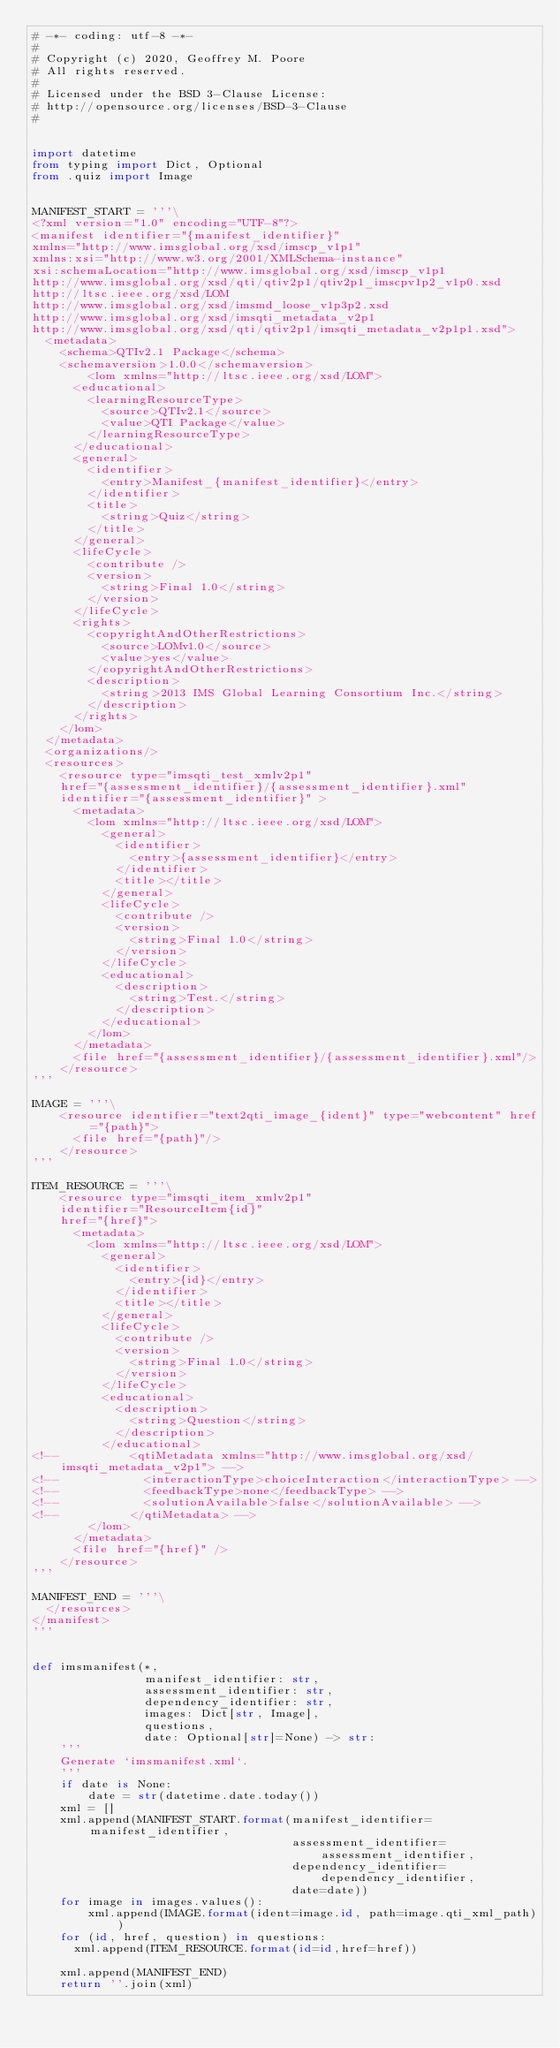<code> <loc_0><loc_0><loc_500><loc_500><_Python_># -*- coding: utf-8 -*-
#
# Copyright (c) 2020, Geoffrey M. Poore
# All rights reserved.
#
# Licensed under the BSD 3-Clause License:
# http://opensource.org/licenses/BSD-3-Clause
#


import datetime
from typing import Dict, Optional
from .quiz import Image


MANIFEST_START = '''\
<?xml version="1.0" encoding="UTF-8"?>
<manifest identifier="{manifest_identifier}"
xmlns="http://www.imsglobal.org/xsd/imscp_v1p1"
xmlns:xsi="http://www.w3.org/2001/XMLSchema-instance" 
xsi:schemaLocation="http://www.imsglobal.org/xsd/imscp_v1p1
http://www.imsglobal.org/xsd/qti/qtiv2p1/qtiv2p1_imscpv1p2_v1p0.xsd
http://ltsc.ieee.org/xsd/LOM 
http://www.imsglobal.org/xsd/imsmd_loose_v1p3p2.xsd                       
http://www.imsglobal.org/xsd/imsqti_metadata_v2p1
http://www.imsglobal.org/xsd/qti/qtiv2p1/imsqti_metadata_v2p1p1.xsd">
  <metadata>
    <schema>QTIv2.1 Package</schema>
    <schemaversion>1.0.0</schemaversion>
        <lom xmlns="http://ltsc.ieee.org/xsd/LOM">
      <educational>
        <learningResourceType>
          <source>QTIv2.1</source>
          <value>QTI Package</value>
        </learningResourceType>
      </educational>
      <general>
        <identifier>
          <entry>Manifest_{manifest_identifier}</entry>
        </identifier>
        <title>
          <string>Quiz</string>
        </title>
      </general>
      <lifeCycle>
        <contribute />
        <version>
          <string>Final 1.0</string>
        </version>
      </lifeCycle>
      <rights>
        <copyrightAndOtherRestrictions>
          <source>LOMv1.0</source>
          <value>yes</value>
        </copyrightAndOtherRestrictions>
        <description>
          <string>2013 IMS Global Learning Consortium Inc.</string>
        </description>
      </rights>
    </lom>
  </metadata>
  <organizations/>
  <resources>
    <resource type="imsqti_test_xmlv2p1"
    href="{assessment_identifier}/{assessment_identifier}.xml"
    identifier="{assessment_identifier}" >
      <metadata>
        <lom xmlns="http://ltsc.ieee.org/xsd/LOM">
          <general>
            <identifier>
              <entry>{assessment_identifier}</entry>
            </identifier>
            <title></title>
          </general>
          <lifeCycle>
            <contribute />
            <version>
              <string>Final 1.0</string>
            </version>
          </lifeCycle>
          <educational>
            <description>
              <string>Test.</string>
            </description>
          </educational>
        </lom>
      </metadata>
      <file href="{assessment_identifier}/{assessment_identifier}.xml"/>
    </resource>
'''

IMAGE = '''\
    <resource identifier="text2qti_image_{ident}" type="webcontent" href="{path}">
      <file href="{path}"/>
    </resource>
'''

ITEM_RESOURCE = '''\
    <resource type="imsqti_item_xmlv2p1"
    identifier="ResourceItem{id}"
    href="{href}">
      <metadata>
        <lom xmlns="http://ltsc.ieee.org/xsd/LOM">
          <general>
            <identifier>
              <entry>{id}</entry>
            </identifier>
            <title></title>
          </general>
          <lifeCycle>
            <contribute />
            <version>
              <string>Final 1.0</string>
            </version>
          </lifeCycle>
          <educational>
            <description>
              <string>Question</string>
            </description>
          </educational>
<!--          <qtiMetadata xmlns="http://www.imsglobal.org/xsd/imsqti_metadata_v2p1"> -->
<!--            <interactionType>choiceInteraction</interactionType> -->
<!--            <feedbackType>none</feedbackType> -->
<!--            <solutionAvailable>false</solutionAvailable> -->
<!--          </qtiMetadata> -->
        </lom>
      </metadata>
      <file href="{href}" />
    </resource>
'''

MANIFEST_END = '''\
  </resources>
</manifest>
'''


def imsmanifest(*,
                manifest_identifier: str,
                assessment_identifier: str,
                dependency_identifier: str,
                images: Dict[str, Image],
                questions,
                date: Optional[str]=None) -> str:
    '''
    Generate `imsmanifest.xml`.
    '''
    if date is None:
        date = str(datetime.date.today())
    xml = []
    xml.append(MANIFEST_START.format(manifest_identifier=manifest_identifier,
                                     assessment_identifier=assessment_identifier,
                                     dependency_identifier=dependency_identifier,
                                     date=date))
    for image in images.values():
        xml.append(IMAGE.format(ident=image.id, path=image.qti_xml_path))
    for (id, href, question) in questions:
      xml.append(ITEM_RESOURCE.format(id=id,href=href))

    xml.append(MANIFEST_END)
    return ''.join(xml)
</code> 